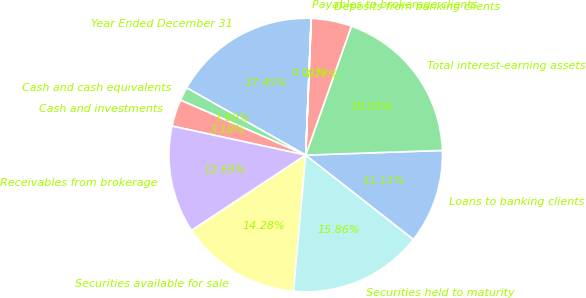Convert chart. <chart><loc_0><loc_0><loc_500><loc_500><pie_chart><fcel>Year Ended December 31<fcel>Cash and cash equivalents<fcel>Cash and investments<fcel>Receivables from brokerage<fcel>Securities available for sale<fcel>Securities held to maturity<fcel>Loans to banking clients<fcel>Total interest-earning assets<fcel>Deposits from banking clients<fcel>Payables to brokerage clients<nl><fcel>17.45%<fcel>1.6%<fcel>3.18%<fcel>12.69%<fcel>14.28%<fcel>15.86%<fcel>11.11%<fcel>19.03%<fcel>4.77%<fcel>0.01%<nl></chart> 